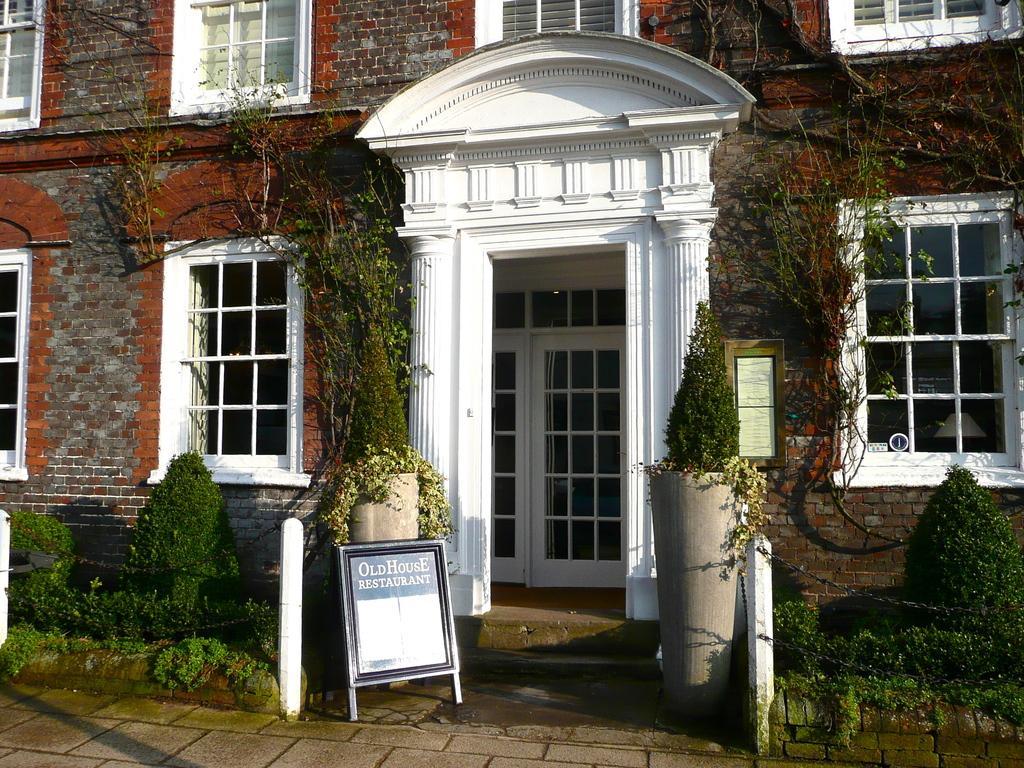Please provide a concise description of this image. In the picture I can see a building which has windows and doors. I can also seen a board which has something written on it, plants, the grass and some other objects on the ground. 